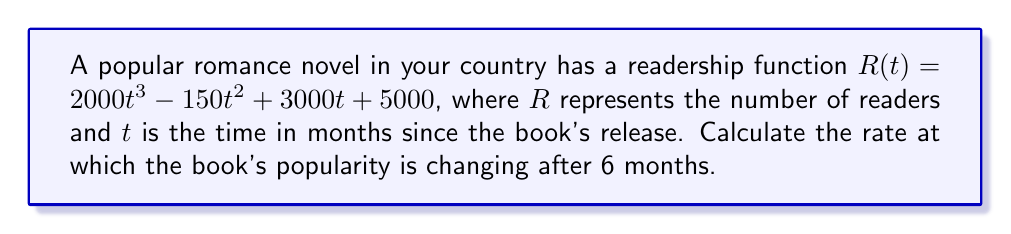Can you solve this math problem? To find the rate of change in the book's popularity after 6 months, we need to follow these steps:

1. The rate of change is represented by the derivative of the readership function $R(t)$.

2. Let's find the derivative $R'(t)$:
   $$R'(t) = \frac{d}{dt}(2000t^3 - 150t^2 + 3000t + 5000)$$
   $$R'(t) = 6000t^2 - 300t + 3000$$

3. Now that we have the derivative, we can find the rate of change at any given time by plugging in the value of $t$.

4. We want to know the rate of change after 6 months, so let's substitute $t = 6$ into $R'(t)$:
   $$R'(6) = 6000(6)^2 - 300(6) + 3000$$
   $$R'(6) = 6000(36) - 1800 + 3000$$
   $$R'(6) = 216000 - 1800 + 3000$$
   $$R'(6) = 217200$$

5. The result, 217200, represents the rate of change in readers per month at $t = 6$ months.
Answer: 217200 readers per month 